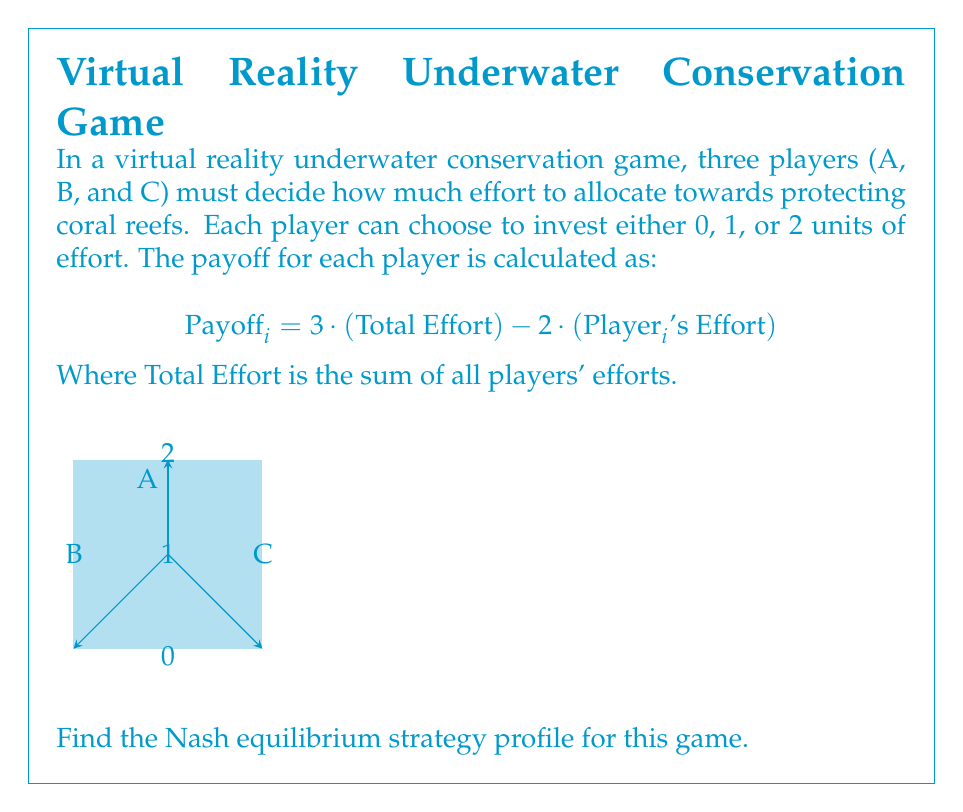Help me with this question. To find the Nash equilibrium, we need to analyze each player's best response to the other players' strategies. Let's approach this step-by-step:

1) First, let's create a payoff matrix for all possible combinations of efforts:

   $$(A,B,C) \quad \text{Total Effort} \quad \text{Payoff A} \quad \text{Payoff B} \quad \text{Payoff C}$$
   $$(0,0,0) \quad 0 \quad 0 \quad 0 \quad 0$$
   $$(1,0,0) \quad 1 \quad 1 \quad 3 \quad 3$$
   $$(2,0,0) \quad 2 \quad 2 \quad 6 \quad 6$$
   $$(1,1,0) \quad 2 \quad 4 \quad 4 \quad 6$$
   $$(2,1,0) \quad 3 \quad 5 \quad 7 \quad 9$$
   $$(1,1,1) \quad 3 \quad 7 \quad 7 \quad 7$$
   $$(2,2,0) \quad 4 \quad 8 \quad 8 \quad 12$$
   $$(2,1,1) \quad 4 \quad 8 \quad 10 \quad 10$$
   $$(2,2,1) \quad 5 \quad 11 \quad 11 \quad 13$$
   $$(2,2,2) \quad 6 \quad 14 \quad 14 \quad 14$$

2) Now, let's analyze each player's best response:

   - If both other players choose 0, a player's best response is 1 (payoff 1 vs 0).
   - If one other player chooses 1 and the other 0, best response is 2 (payoff 5 vs 4).
   - If both other players choose 1, best response is 2 (payoff 8 vs 7).
   - If one other player chooses 2 and the other 1, best response is 2 (payoff 11 vs 10).
   - If both other players choose 2, best response is 2 (payoff 14 vs 13).

3) We can see that choosing 2 is always the best response, regardless of what the other players do. This is called a dominant strategy.

4) Since all players have the same payoff structure, they all have the same dominant strategy of choosing 2.

5) Therefore, the Nash equilibrium is reached when all players choose their dominant strategy: (2,2,2).

6) At this equilibrium, each player receives a payoff of 14.

This Nash equilibrium demonstrates the "Tragedy of the Commons" in conservation efforts. While it would be collectively better if players coordinated to choose (1,1,1) (total payoff 21 vs 42), individual incentives lead to overexploitation of resources.
Answer: (2,2,2) 